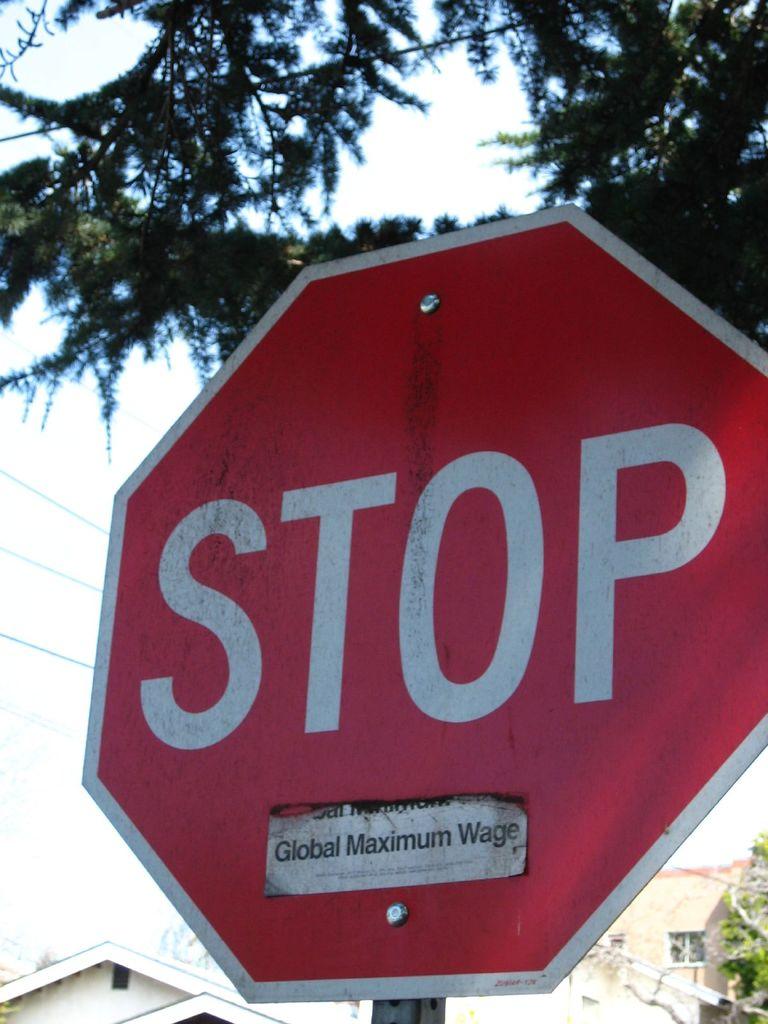What street sign is shown here?
Make the answer very short. Stop. 